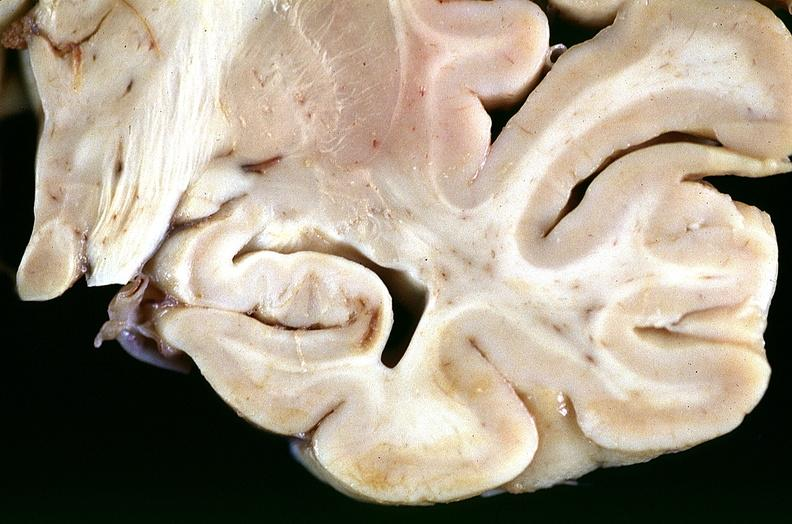s nervous present?
Answer the question using a single word or phrase. Yes 